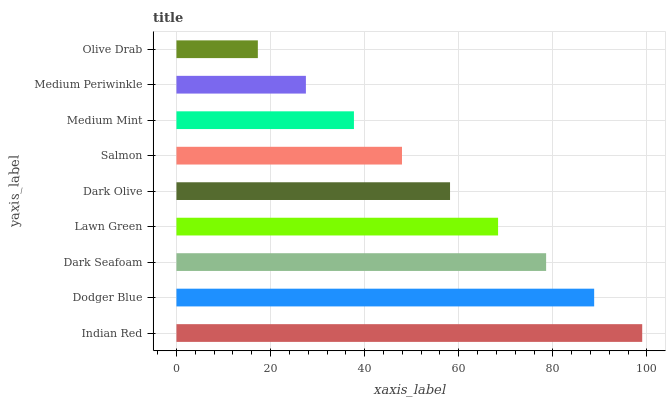Is Olive Drab the minimum?
Answer yes or no. Yes. Is Indian Red the maximum?
Answer yes or no. Yes. Is Dodger Blue the minimum?
Answer yes or no. No. Is Dodger Blue the maximum?
Answer yes or no. No. Is Indian Red greater than Dodger Blue?
Answer yes or no. Yes. Is Dodger Blue less than Indian Red?
Answer yes or no. Yes. Is Dodger Blue greater than Indian Red?
Answer yes or no. No. Is Indian Red less than Dodger Blue?
Answer yes or no. No. Is Dark Olive the high median?
Answer yes or no. Yes. Is Dark Olive the low median?
Answer yes or no. Yes. Is Indian Red the high median?
Answer yes or no. No. Is Olive Drab the low median?
Answer yes or no. No. 